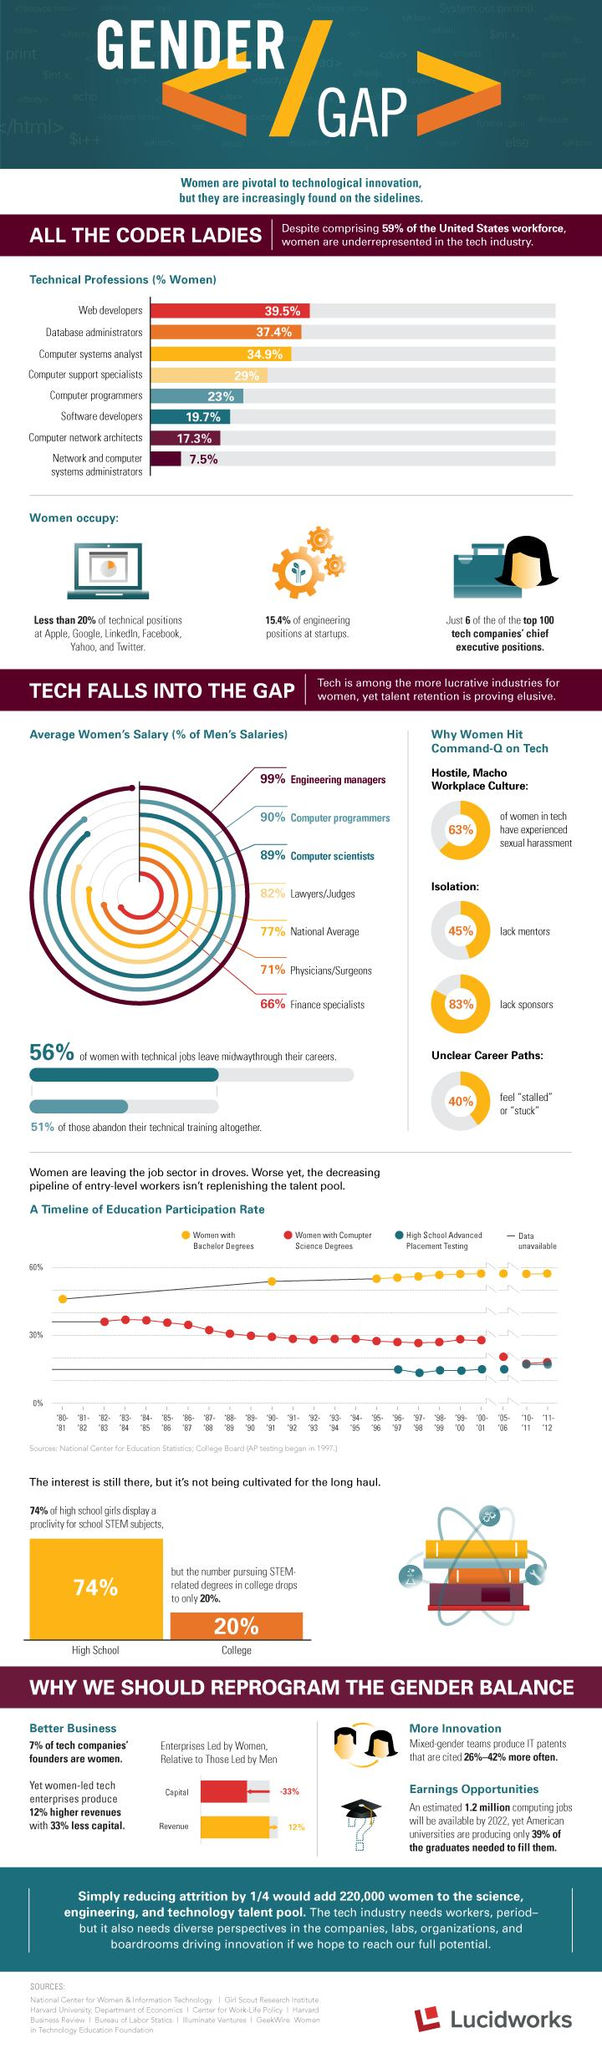Point out several critical features in this image. In the years 2005-2006, approximately 20% of those pursuing computer science degrees were women. 